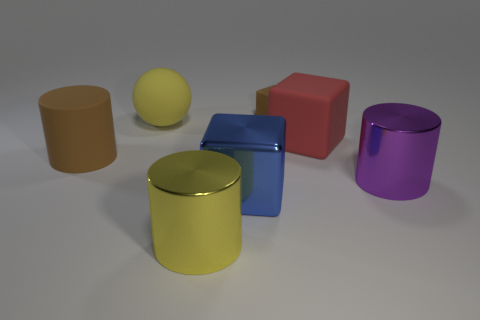Are there any other things that are the same shape as the yellow matte thing?
Provide a short and direct response. No. What is the material of the cylinder that is the same color as the small object?
Offer a terse response. Rubber. There is a large red object; does it have the same shape as the yellow object that is behind the yellow shiny cylinder?
Keep it short and to the point. No. There is a big blue object that is the same material as the purple cylinder; what is its shape?
Offer a terse response. Cube. Are there more large cubes that are on the right side of the large blue metal cube than big yellow cylinders that are behind the big matte block?
Your answer should be compact. Yes. How many things are small yellow shiny cubes or matte blocks?
Your answer should be very brief. 2. What number of other things are there of the same color as the small rubber cube?
Your answer should be very brief. 1. What shape is the yellow metal object that is the same size as the red rubber object?
Make the answer very short. Cylinder. What color is the large cube that is in front of the rubber cylinder?
Offer a terse response. Blue. What number of objects are metallic cylinders left of the purple shiny thing or things that are behind the brown matte cylinder?
Offer a terse response. 4. 